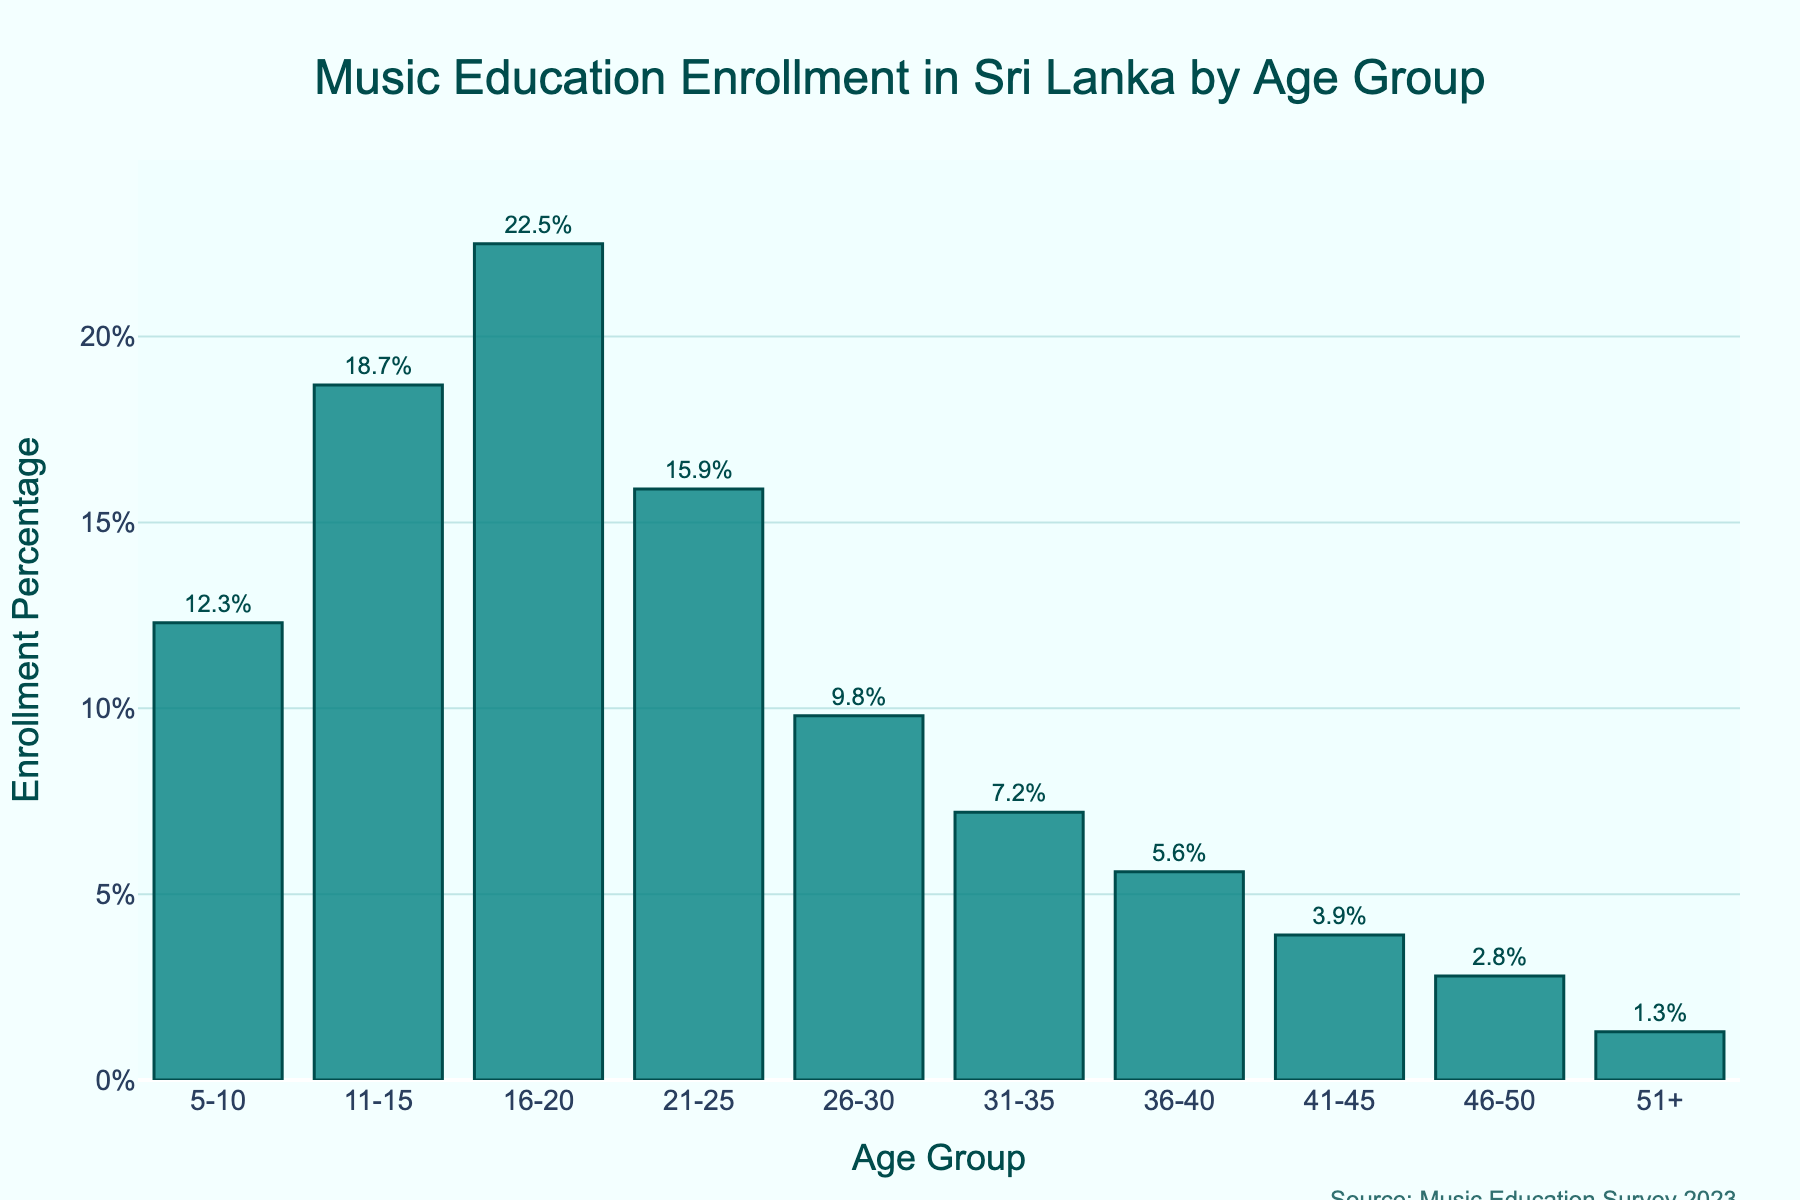What age group has the highest enrollment percentage? Looking at the bar chart, the tallest bar indicates the highest enrollment percentage. The age group 16-20 has the highest enrollment percentage at 22.5%.
Answer: 16-20 Which age group has a higher enrollment percentage: 21-25 or 26-30? Compare the heights of the bars for 21-25 and 26-30. The bar for 21-25 is taller, showing an enrollment percentage of 15.9%, which is higher than 9.8% for 26-30.
Answer: 21-25 What is the difference in enrollment percentage between the 16-20 and 31-35 age groups? The enrollment percentage for 16-20 is 22.5%, and for 31-35 it is 7.2%. The difference is 22.5% - 7.2% = 15.3%.
Answer: 15.3% Sum the enrollment percentages of the youngest and oldest age groups presented. The youngest age group (5-10) has an enrollment percentage of 12.3%, and the oldest age group (51+) has an enrollment percentage of 1.3%. Adding them together: 12.3% + 1.3% = 13.6%.
Answer: 13.6% What is the total percentage of enrollment for age groups 5-10 and 11-15 combined? The enrollment percentage for 5-10 is 12.3% and for 11-15 it is 18.7%. Adding these, the total is 12.3% + 18.7% = 31.0%.
Answer: 31.0% What is the median enrollment percentage for the displayed age groups? To find the median, list the enrollment percentages in ascending order: 1.3%, 2.8%, 3.9%, 5.6%, 7.2%, 9.8%, 12.3%, 15.9%, 18.7%, 22.5%. The middle two values are 7.2% and 9.8%. The median is the average of these two, (7.2% + 9.8%) / 2 = 8.5%.
Answer: 8.5% Which age group has less than half the enrollment percentage of the 16-20 age group? The enrollment percentage for 16-20 is 22.5%. Half of this value is 11.25%. Any group with less than 11.25% meets the condition: 26-30 (9.8%), 31-35 (7.2%), 36-40 (5.6%), 41-45 (3.9%), 46-50 (2.8%), 51+ (1.3%).
Answer: 26-30, 31-35, 36-40, 41-45, 46-50, 51+ Which two adjacent age groups have the largest difference in enrollment percentages? Compare the differences between adjacent age groups: The largest difference is between 16-20 (22.5%) and 21-25 (15.9%), which is 22.5% - 15.9% = 6.6%.
Answer: 16-20 and 21-25 